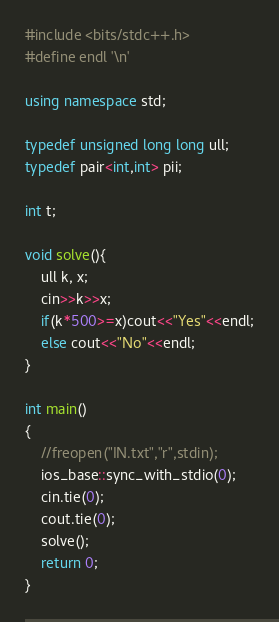Convert code to text. <code><loc_0><loc_0><loc_500><loc_500><_C++_>#include <bits/stdc++.h>
#define endl '\n'

using namespace std;

typedef unsigned long long ull;
typedef pair<int,int> pii;

int t;

void solve(){
    ull k, x;
    cin>>k>>x;
    if(k*500>=x)cout<<"Yes"<<endl;
    else cout<<"No"<<endl;
}

int main()
{
    //freopen("IN.txt","r",stdin);
    ios_base::sync_with_stdio(0);
    cin.tie(0);
    cout.tie(0);
    solve();
    return 0;
}
</code> 